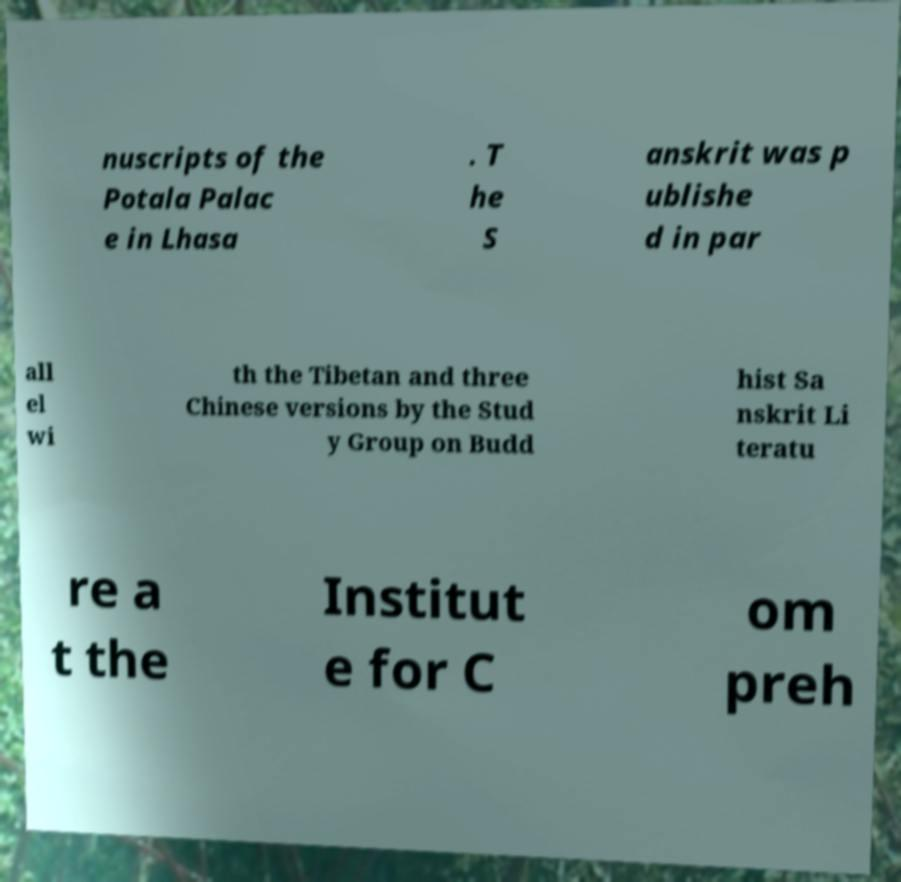For documentation purposes, I need the text within this image transcribed. Could you provide that? nuscripts of the Potala Palac e in Lhasa . T he S anskrit was p ublishe d in par all el wi th the Tibetan and three Chinese versions by the Stud y Group on Budd hist Sa nskrit Li teratu re a t the Institut e for C om preh 